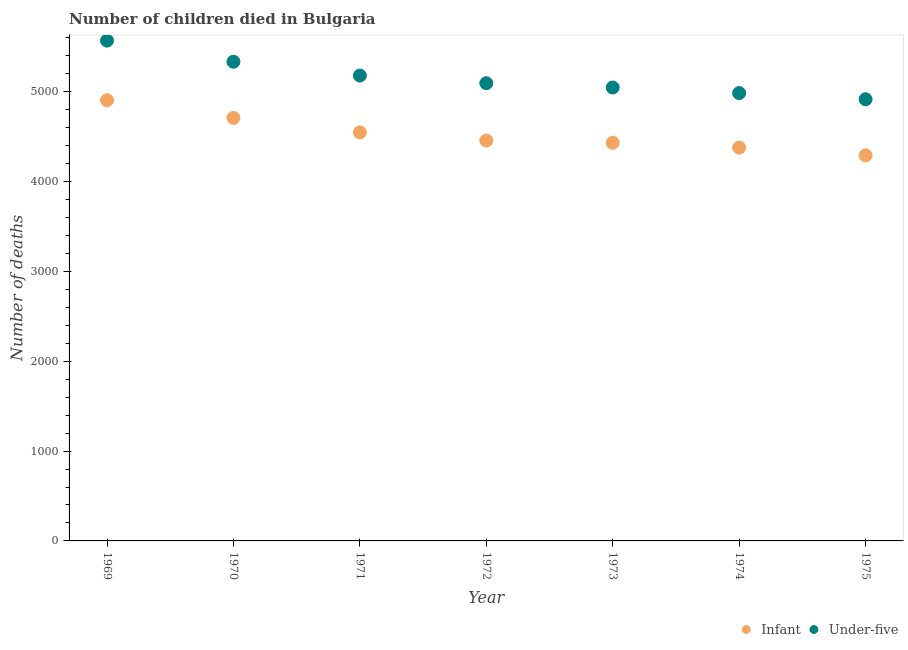How many different coloured dotlines are there?
Give a very brief answer. 2. What is the number of under-five deaths in 1970?
Provide a short and direct response. 5333. Across all years, what is the maximum number of under-five deaths?
Give a very brief answer. 5568. Across all years, what is the minimum number of under-five deaths?
Give a very brief answer. 4915. In which year was the number of under-five deaths maximum?
Your response must be concise. 1969. In which year was the number of infant deaths minimum?
Provide a succinct answer. 1975. What is the total number of infant deaths in the graph?
Make the answer very short. 3.17e+04. What is the difference between the number of infant deaths in 1970 and that in 1972?
Offer a very short reply. 252. What is the difference between the number of infant deaths in 1972 and the number of under-five deaths in 1969?
Your response must be concise. -1112. What is the average number of infant deaths per year?
Offer a very short reply. 4530.57. In the year 1969, what is the difference between the number of infant deaths and number of under-five deaths?
Ensure brevity in your answer.  -664. In how many years, is the number of under-five deaths greater than 4800?
Give a very brief answer. 7. What is the ratio of the number of under-five deaths in 1969 to that in 1972?
Ensure brevity in your answer.  1.09. Is the number of infant deaths in 1973 less than that in 1975?
Give a very brief answer. No. What is the difference between the highest and the second highest number of infant deaths?
Offer a very short reply. 196. What is the difference between the highest and the lowest number of under-five deaths?
Your answer should be compact. 653. In how many years, is the number of infant deaths greater than the average number of infant deaths taken over all years?
Keep it short and to the point. 3. Is the sum of the number of infant deaths in 1969 and 1971 greater than the maximum number of under-five deaths across all years?
Your answer should be very brief. Yes. Does the number of under-five deaths monotonically increase over the years?
Offer a very short reply. No. How many dotlines are there?
Make the answer very short. 2. How many years are there in the graph?
Offer a very short reply. 7. What is the difference between two consecutive major ticks on the Y-axis?
Your answer should be compact. 1000. Are the values on the major ticks of Y-axis written in scientific E-notation?
Offer a terse response. No. Does the graph contain grids?
Your answer should be very brief. No. How are the legend labels stacked?
Ensure brevity in your answer.  Horizontal. What is the title of the graph?
Give a very brief answer. Number of children died in Bulgaria. Does "Forest land" appear as one of the legend labels in the graph?
Give a very brief answer. No. What is the label or title of the Y-axis?
Make the answer very short. Number of deaths. What is the Number of deaths of Infant in 1969?
Your answer should be compact. 4904. What is the Number of deaths of Under-five in 1969?
Your response must be concise. 5568. What is the Number of deaths of Infant in 1970?
Your answer should be very brief. 4708. What is the Number of deaths in Under-five in 1970?
Your response must be concise. 5333. What is the Number of deaths of Infant in 1971?
Offer a terse response. 4547. What is the Number of deaths of Under-five in 1971?
Provide a succinct answer. 5179. What is the Number of deaths in Infant in 1972?
Make the answer very short. 4456. What is the Number of deaths of Under-five in 1972?
Offer a terse response. 5094. What is the Number of deaths of Infant in 1973?
Give a very brief answer. 4431. What is the Number of deaths of Under-five in 1973?
Provide a succinct answer. 5046. What is the Number of deaths of Infant in 1974?
Offer a terse response. 4377. What is the Number of deaths in Under-five in 1974?
Give a very brief answer. 4984. What is the Number of deaths in Infant in 1975?
Your answer should be compact. 4291. What is the Number of deaths in Under-five in 1975?
Offer a terse response. 4915. Across all years, what is the maximum Number of deaths in Infant?
Your response must be concise. 4904. Across all years, what is the maximum Number of deaths of Under-five?
Make the answer very short. 5568. Across all years, what is the minimum Number of deaths of Infant?
Give a very brief answer. 4291. Across all years, what is the minimum Number of deaths of Under-five?
Your answer should be compact. 4915. What is the total Number of deaths of Infant in the graph?
Give a very brief answer. 3.17e+04. What is the total Number of deaths of Under-five in the graph?
Give a very brief answer. 3.61e+04. What is the difference between the Number of deaths in Infant in 1969 and that in 1970?
Offer a terse response. 196. What is the difference between the Number of deaths in Under-five in 1969 and that in 1970?
Ensure brevity in your answer.  235. What is the difference between the Number of deaths of Infant in 1969 and that in 1971?
Ensure brevity in your answer.  357. What is the difference between the Number of deaths in Under-five in 1969 and that in 1971?
Give a very brief answer. 389. What is the difference between the Number of deaths in Infant in 1969 and that in 1972?
Offer a terse response. 448. What is the difference between the Number of deaths of Under-five in 1969 and that in 1972?
Ensure brevity in your answer.  474. What is the difference between the Number of deaths of Infant in 1969 and that in 1973?
Keep it short and to the point. 473. What is the difference between the Number of deaths in Under-five in 1969 and that in 1973?
Ensure brevity in your answer.  522. What is the difference between the Number of deaths of Infant in 1969 and that in 1974?
Keep it short and to the point. 527. What is the difference between the Number of deaths in Under-five in 1969 and that in 1974?
Offer a very short reply. 584. What is the difference between the Number of deaths in Infant in 1969 and that in 1975?
Your answer should be very brief. 613. What is the difference between the Number of deaths of Under-five in 1969 and that in 1975?
Provide a short and direct response. 653. What is the difference between the Number of deaths in Infant in 1970 and that in 1971?
Keep it short and to the point. 161. What is the difference between the Number of deaths in Under-five in 1970 and that in 1971?
Make the answer very short. 154. What is the difference between the Number of deaths of Infant in 1970 and that in 1972?
Offer a very short reply. 252. What is the difference between the Number of deaths in Under-five in 1970 and that in 1972?
Give a very brief answer. 239. What is the difference between the Number of deaths of Infant in 1970 and that in 1973?
Provide a short and direct response. 277. What is the difference between the Number of deaths in Under-five in 1970 and that in 1973?
Make the answer very short. 287. What is the difference between the Number of deaths in Infant in 1970 and that in 1974?
Your answer should be compact. 331. What is the difference between the Number of deaths in Under-five in 1970 and that in 1974?
Provide a short and direct response. 349. What is the difference between the Number of deaths of Infant in 1970 and that in 1975?
Ensure brevity in your answer.  417. What is the difference between the Number of deaths of Under-five in 1970 and that in 1975?
Make the answer very short. 418. What is the difference between the Number of deaths of Infant in 1971 and that in 1972?
Your answer should be very brief. 91. What is the difference between the Number of deaths in Under-five in 1971 and that in 1972?
Keep it short and to the point. 85. What is the difference between the Number of deaths in Infant in 1971 and that in 1973?
Provide a short and direct response. 116. What is the difference between the Number of deaths of Under-five in 1971 and that in 1973?
Provide a short and direct response. 133. What is the difference between the Number of deaths of Infant in 1971 and that in 1974?
Give a very brief answer. 170. What is the difference between the Number of deaths in Under-five in 1971 and that in 1974?
Your answer should be compact. 195. What is the difference between the Number of deaths in Infant in 1971 and that in 1975?
Offer a terse response. 256. What is the difference between the Number of deaths of Under-five in 1971 and that in 1975?
Make the answer very short. 264. What is the difference between the Number of deaths in Infant in 1972 and that in 1973?
Your answer should be very brief. 25. What is the difference between the Number of deaths of Under-five in 1972 and that in 1973?
Ensure brevity in your answer.  48. What is the difference between the Number of deaths of Infant in 1972 and that in 1974?
Make the answer very short. 79. What is the difference between the Number of deaths in Under-five in 1972 and that in 1974?
Your answer should be very brief. 110. What is the difference between the Number of deaths of Infant in 1972 and that in 1975?
Ensure brevity in your answer.  165. What is the difference between the Number of deaths in Under-five in 1972 and that in 1975?
Offer a very short reply. 179. What is the difference between the Number of deaths of Infant in 1973 and that in 1975?
Provide a succinct answer. 140. What is the difference between the Number of deaths in Under-five in 1973 and that in 1975?
Provide a short and direct response. 131. What is the difference between the Number of deaths in Infant in 1974 and that in 1975?
Ensure brevity in your answer.  86. What is the difference between the Number of deaths in Under-five in 1974 and that in 1975?
Offer a very short reply. 69. What is the difference between the Number of deaths in Infant in 1969 and the Number of deaths in Under-five in 1970?
Provide a short and direct response. -429. What is the difference between the Number of deaths of Infant in 1969 and the Number of deaths of Under-five in 1971?
Give a very brief answer. -275. What is the difference between the Number of deaths of Infant in 1969 and the Number of deaths of Under-five in 1972?
Ensure brevity in your answer.  -190. What is the difference between the Number of deaths of Infant in 1969 and the Number of deaths of Under-five in 1973?
Your answer should be very brief. -142. What is the difference between the Number of deaths in Infant in 1969 and the Number of deaths in Under-five in 1974?
Your answer should be very brief. -80. What is the difference between the Number of deaths in Infant in 1969 and the Number of deaths in Under-five in 1975?
Make the answer very short. -11. What is the difference between the Number of deaths of Infant in 1970 and the Number of deaths of Under-five in 1971?
Keep it short and to the point. -471. What is the difference between the Number of deaths of Infant in 1970 and the Number of deaths of Under-five in 1972?
Offer a very short reply. -386. What is the difference between the Number of deaths of Infant in 1970 and the Number of deaths of Under-five in 1973?
Your answer should be compact. -338. What is the difference between the Number of deaths of Infant in 1970 and the Number of deaths of Under-five in 1974?
Keep it short and to the point. -276. What is the difference between the Number of deaths in Infant in 1970 and the Number of deaths in Under-five in 1975?
Your response must be concise. -207. What is the difference between the Number of deaths of Infant in 1971 and the Number of deaths of Under-five in 1972?
Provide a short and direct response. -547. What is the difference between the Number of deaths of Infant in 1971 and the Number of deaths of Under-five in 1973?
Your answer should be compact. -499. What is the difference between the Number of deaths of Infant in 1971 and the Number of deaths of Under-five in 1974?
Your answer should be very brief. -437. What is the difference between the Number of deaths in Infant in 1971 and the Number of deaths in Under-five in 1975?
Keep it short and to the point. -368. What is the difference between the Number of deaths of Infant in 1972 and the Number of deaths of Under-five in 1973?
Provide a short and direct response. -590. What is the difference between the Number of deaths of Infant in 1972 and the Number of deaths of Under-five in 1974?
Provide a short and direct response. -528. What is the difference between the Number of deaths of Infant in 1972 and the Number of deaths of Under-five in 1975?
Your answer should be very brief. -459. What is the difference between the Number of deaths in Infant in 1973 and the Number of deaths in Under-five in 1974?
Your answer should be compact. -553. What is the difference between the Number of deaths in Infant in 1973 and the Number of deaths in Under-five in 1975?
Your answer should be very brief. -484. What is the difference between the Number of deaths in Infant in 1974 and the Number of deaths in Under-five in 1975?
Your answer should be compact. -538. What is the average Number of deaths of Infant per year?
Provide a succinct answer. 4530.57. What is the average Number of deaths in Under-five per year?
Make the answer very short. 5159.86. In the year 1969, what is the difference between the Number of deaths in Infant and Number of deaths in Under-five?
Offer a very short reply. -664. In the year 1970, what is the difference between the Number of deaths of Infant and Number of deaths of Under-five?
Provide a short and direct response. -625. In the year 1971, what is the difference between the Number of deaths of Infant and Number of deaths of Under-five?
Provide a short and direct response. -632. In the year 1972, what is the difference between the Number of deaths of Infant and Number of deaths of Under-five?
Give a very brief answer. -638. In the year 1973, what is the difference between the Number of deaths in Infant and Number of deaths in Under-five?
Keep it short and to the point. -615. In the year 1974, what is the difference between the Number of deaths of Infant and Number of deaths of Under-five?
Provide a succinct answer. -607. In the year 1975, what is the difference between the Number of deaths of Infant and Number of deaths of Under-five?
Offer a terse response. -624. What is the ratio of the Number of deaths of Infant in 1969 to that in 1970?
Keep it short and to the point. 1.04. What is the ratio of the Number of deaths in Under-five in 1969 to that in 1970?
Offer a very short reply. 1.04. What is the ratio of the Number of deaths in Infant in 1969 to that in 1971?
Make the answer very short. 1.08. What is the ratio of the Number of deaths in Under-five in 1969 to that in 1971?
Your answer should be compact. 1.08. What is the ratio of the Number of deaths in Infant in 1969 to that in 1972?
Your answer should be compact. 1.1. What is the ratio of the Number of deaths of Under-five in 1969 to that in 1972?
Give a very brief answer. 1.09. What is the ratio of the Number of deaths of Infant in 1969 to that in 1973?
Provide a succinct answer. 1.11. What is the ratio of the Number of deaths in Under-five in 1969 to that in 1973?
Your answer should be very brief. 1.1. What is the ratio of the Number of deaths of Infant in 1969 to that in 1974?
Offer a very short reply. 1.12. What is the ratio of the Number of deaths of Under-five in 1969 to that in 1974?
Your answer should be very brief. 1.12. What is the ratio of the Number of deaths in Under-five in 1969 to that in 1975?
Give a very brief answer. 1.13. What is the ratio of the Number of deaths in Infant in 1970 to that in 1971?
Provide a succinct answer. 1.04. What is the ratio of the Number of deaths of Under-five in 1970 to that in 1971?
Offer a very short reply. 1.03. What is the ratio of the Number of deaths of Infant in 1970 to that in 1972?
Ensure brevity in your answer.  1.06. What is the ratio of the Number of deaths of Under-five in 1970 to that in 1972?
Offer a very short reply. 1.05. What is the ratio of the Number of deaths in Infant in 1970 to that in 1973?
Give a very brief answer. 1.06. What is the ratio of the Number of deaths of Under-five in 1970 to that in 1973?
Make the answer very short. 1.06. What is the ratio of the Number of deaths of Infant in 1970 to that in 1974?
Offer a terse response. 1.08. What is the ratio of the Number of deaths in Under-five in 1970 to that in 1974?
Keep it short and to the point. 1.07. What is the ratio of the Number of deaths of Infant in 1970 to that in 1975?
Provide a succinct answer. 1.1. What is the ratio of the Number of deaths of Under-five in 1970 to that in 1975?
Your answer should be very brief. 1.08. What is the ratio of the Number of deaths of Infant in 1971 to that in 1972?
Your response must be concise. 1.02. What is the ratio of the Number of deaths of Under-five in 1971 to that in 1972?
Provide a short and direct response. 1.02. What is the ratio of the Number of deaths of Infant in 1971 to that in 1973?
Your answer should be compact. 1.03. What is the ratio of the Number of deaths of Under-five in 1971 to that in 1973?
Provide a succinct answer. 1.03. What is the ratio of the Number of deaths in Infant in 1971 to that in 1974?
Your answer should be very brief. 1.04. What is the ratio of the Number of deaths of Under-five in 1971 to that in 1974?
Offer a very short reply. 1.04. What is the ratio of the Number of deaths in Infant in 1971 to that in 1975?
Provide a short and direct response. 1.06. What is the ratio of the Number of deaths in Under-five in 1971 to that in 1975?
Ensure brevity in your answer.  1.05. What is the ratio of the Number of deaths in Infant in 1972 to that in 1973?
Ensure brevity in your answer.  1.01. What is the ratio of the Number of deaths in Under-five in 1972 to that in 1973?
Your response must be concise. 1.01. What is the ratio of the Number of deaths of Infant in 1972 to that in 1974?
Make the answer very short. 1.02. What is the ratio of the Number of deaths of Under-five in 1972 to that in 1974?
Provide a short and direct response. 1.02. What is the ratio of the Number of deaths of Under-five in 1972 to that in 1975?
Give a very brief answer. 1.04. What is the ratio of the Number of deaths of Infant in 1973 to that in 1974?
Give a very brief answer. 1.01. What is the ratio of the Number of deaths of Under-five in 1973 to that in 1974?
Your answer should be very brief. 1.01. What is the ratio of the Number of deaths of Infant in 1973 to that in 1975?
Your answer should be very brief. 1.03. What is the ratio of the Number of deaths of Under-five in 1973 to that in 1975?
Provide a succinct answer. 1.03. What is the ratio of the Number of deaths in Infant in 1974 to that in 1975?
Offer a terse response. 1.02. What is the ratio of the Number of deaths in Under-five in 1974 to that in 1975?
Offer a terse response. 1.01. What is the difference between the highest and the second highest Number of deaths of Infant?
Your answer should be compact. 196. What is the difference between the highest and the second highest Number of deaths of Under-five?
Keep it short and to the point. 235. What is the difference between the highest and the lowest Number of deaths of Infant?
Ensure brevity in your answer.  613. What is the difference between the highest and the lowest Number of deaths in Under-five?
Offer a very short reply. 653. 